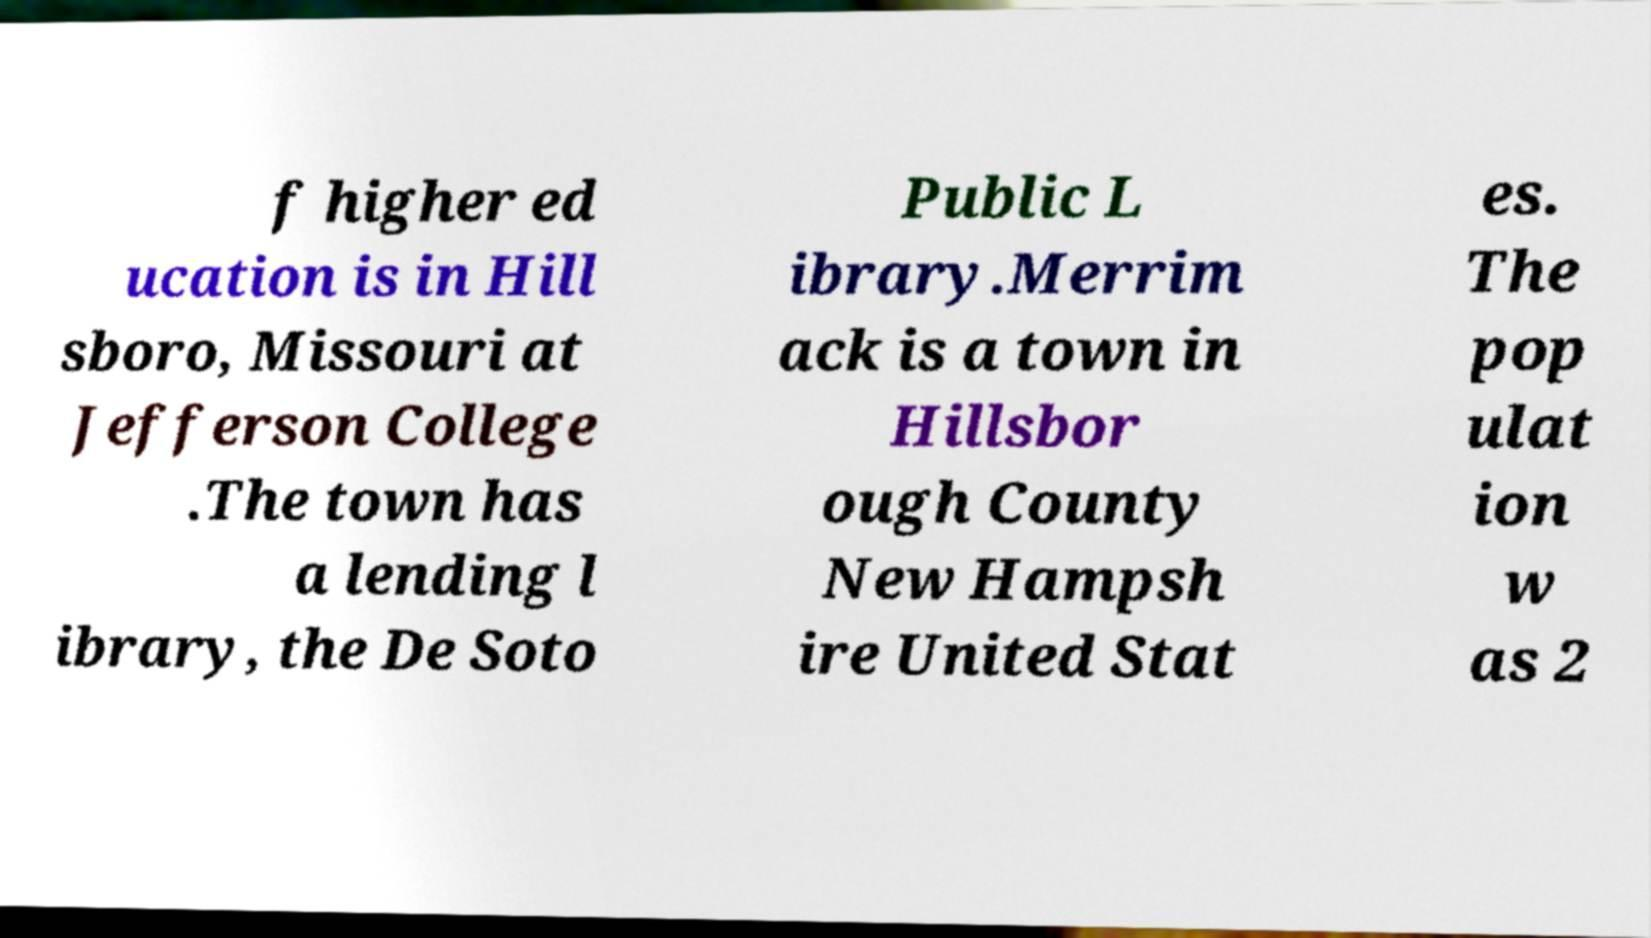I need the written content from this picture converted into text. Can you do that? f higher ed ucation is in Hill sboro, Missouri at Jefferson College .The town has a lending l ibrary, the De Soto Public L ibrary.Merrim ack is a town in Hillsbor ough County New Hampsh ire United Stat es. The pop ulat ion w as 2 